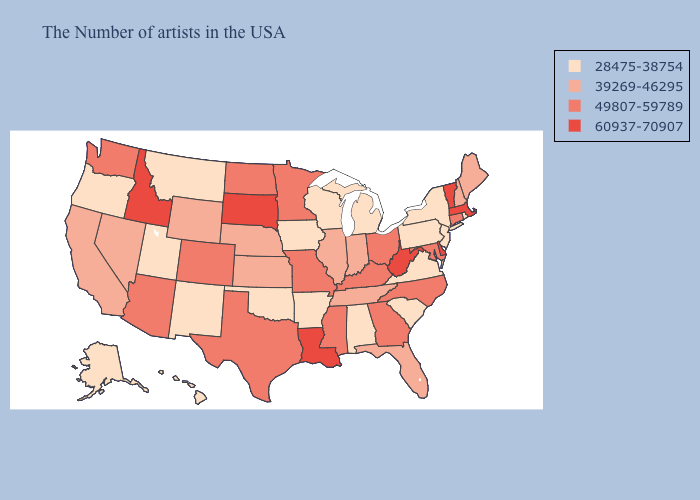What is the lowest value in states that border Kansas?
Write a very short answer. 28475-38754. Does Washington have a higher value than Colorado?
Concise answer only. No. Does the first symbol in the legend represent the smallest category?
Quick response, please. Yes. Name the states that have a value in the range 39269-46295?
Write a very short answer. Maine, New Hampshire, Florida, Indiana, Tennessee, Illinois, Kansas, Nebraska, Wyoming, Nevada, California. Among the states that border Illinois , does Kentucky have the lowest value?
Keep it brief. No. Name the states that have a value in the range 39269-46295?
Give a very brief answer. Maine, New Hampshire, Florida, Indiana, Tennessee, Illinois, Kansas, Nebraska, Wyoming, Nevada, California. What is the value of Indiana?
Be succinct. 39269-46295. Among the states that border Delaware , does Maryland have the highest value?
Concise answer only. Yes. Among the states that border Vermont , which have the lowest value?
Quick response, please. New York. Does Vermont have the same value as Missouri?
Write a very short answer. No. What is the value of Mississippi?
Keep it brief. 49807-59789. Which states have the lowest value in the MidWest?
Write a very short answer. Michigan, Wisconsin, Iowa. Does Massachusetts have the highest value in the Northeast?
Answer briefly. Yes. Does New York have a lower value than Iowa?
Write a very short answer. No. What is the value of Vermont?
Give a very brief answer. 60937-70907. 